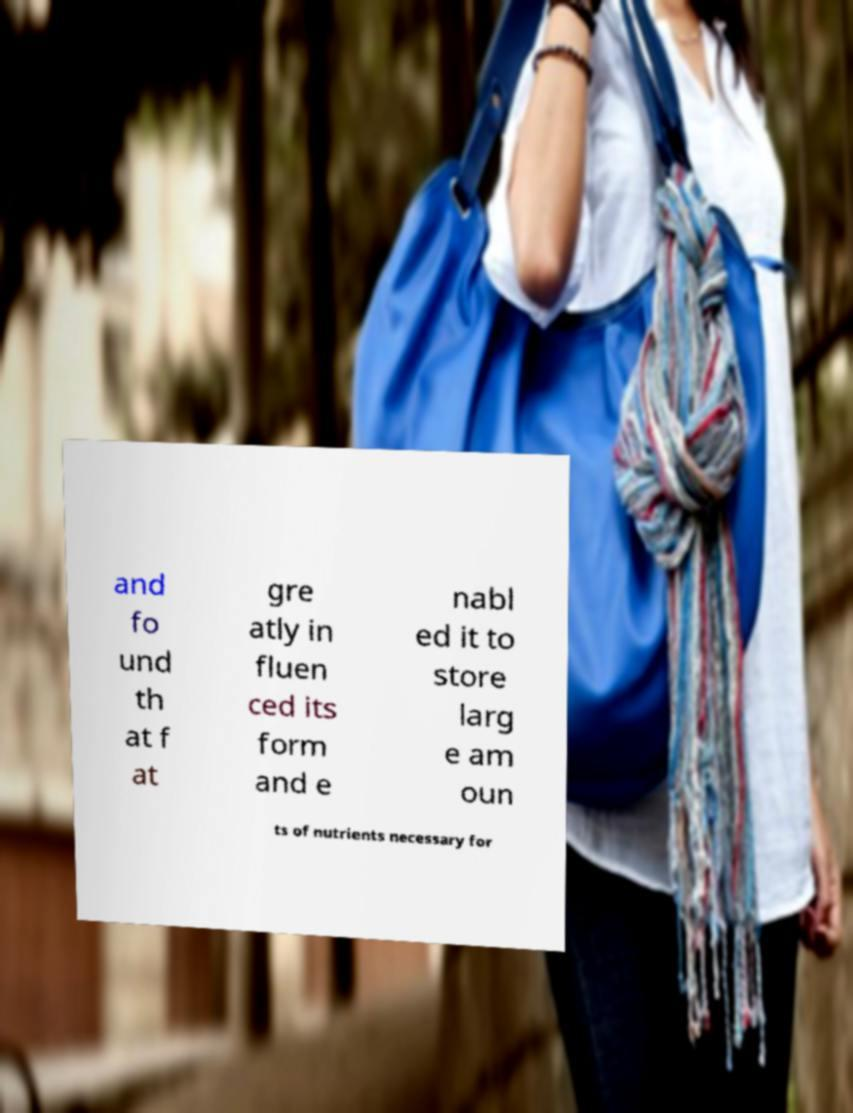There's text embedded in this image that I need extracted. Can you transcribe it verbatim? and fo und th at f at gre atly in fluen ced its form and e nabl ed it to store larg e am oun ts of nutrients necessary for 